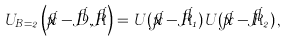Convert formula to latex. <formula><loc_0><loc_0><loc_500><loc_500>U _ { B = 2 } \left ( \vec { x } - \vec { D } , \vec { R } \right ) = U ( \vec { x } - \vec { R } _ { 1 } ) U ( \vec { x } - \vec { R } _ { 2 } ) \, ,</formula> 